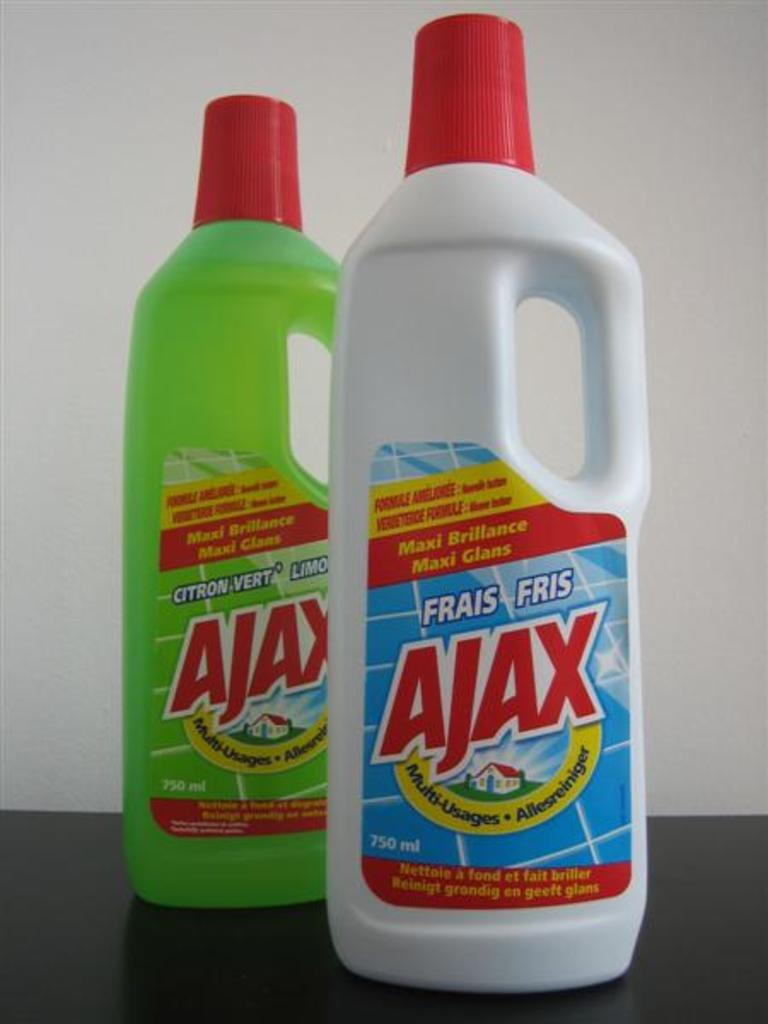<image>
Give a short and clear explanation of the subsequent image. Two bottles of Ajax sit on a table. 